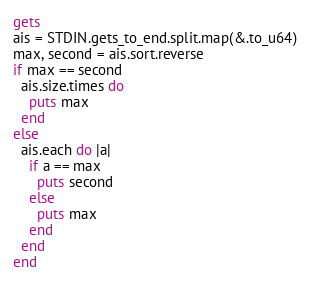<code> <loc_0><loc_0><loc_500><loc_500><_Crystal_>gets
ais = STDIN.gets_to_end.split.map(&.to_u64)
max, second = ais.sort.reverse
if max == second
  ais.size.times do
    puts max
  end
else
  ais.each do |a|
    if a == max
      puts second
    else
      puts max
    end
  end
end
</code> 